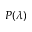Convert formula to latex. <formula><loc_0><loc_0><loc_500><loc_500>P ( \lambda )</formula> 